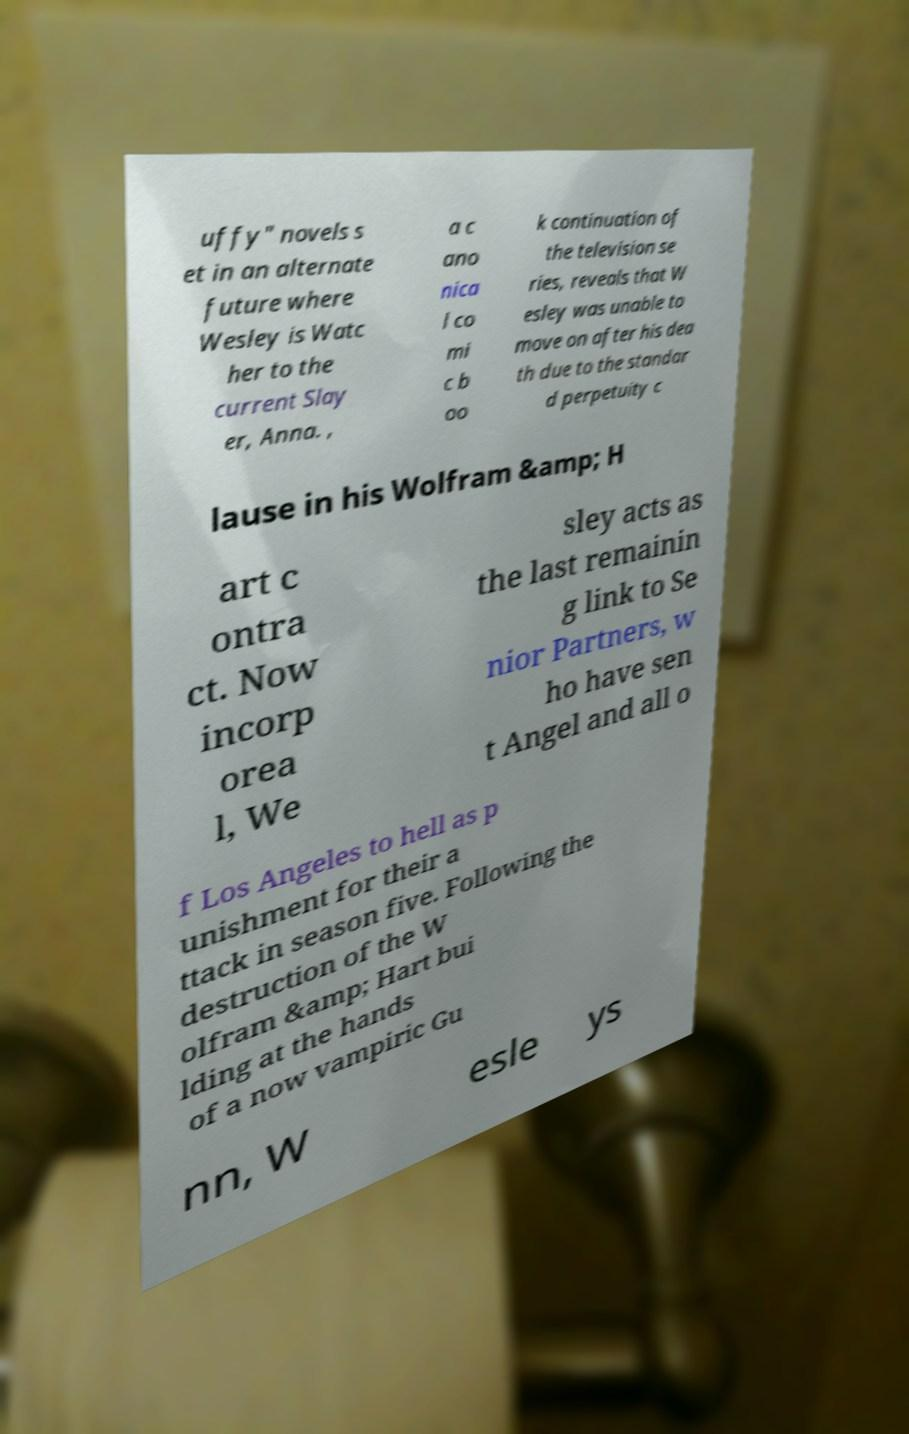Could you extract and type out the text from this image? uffy" novels s et in an alternate future where Wesley is Watc her to the current Slay er, Anna. , a c ano nica l co mi c b oo k continuation of the television se ries, reveals that W esley was unable to move on after his dea th due to the standar d perpetuity c lause in his Wolfram &amp; H art c ontra ct. Now incorp orea l, We sley acts as the last remainin g link to Se nior Partners, w ho have sen t Angel and all o f Los Angeles to hell as p unishment for their a ttack in season five. Following the destruction of the W olfram &amp; Hart bui lding at the hands of a now vampiric Gu nn, W esle ys 